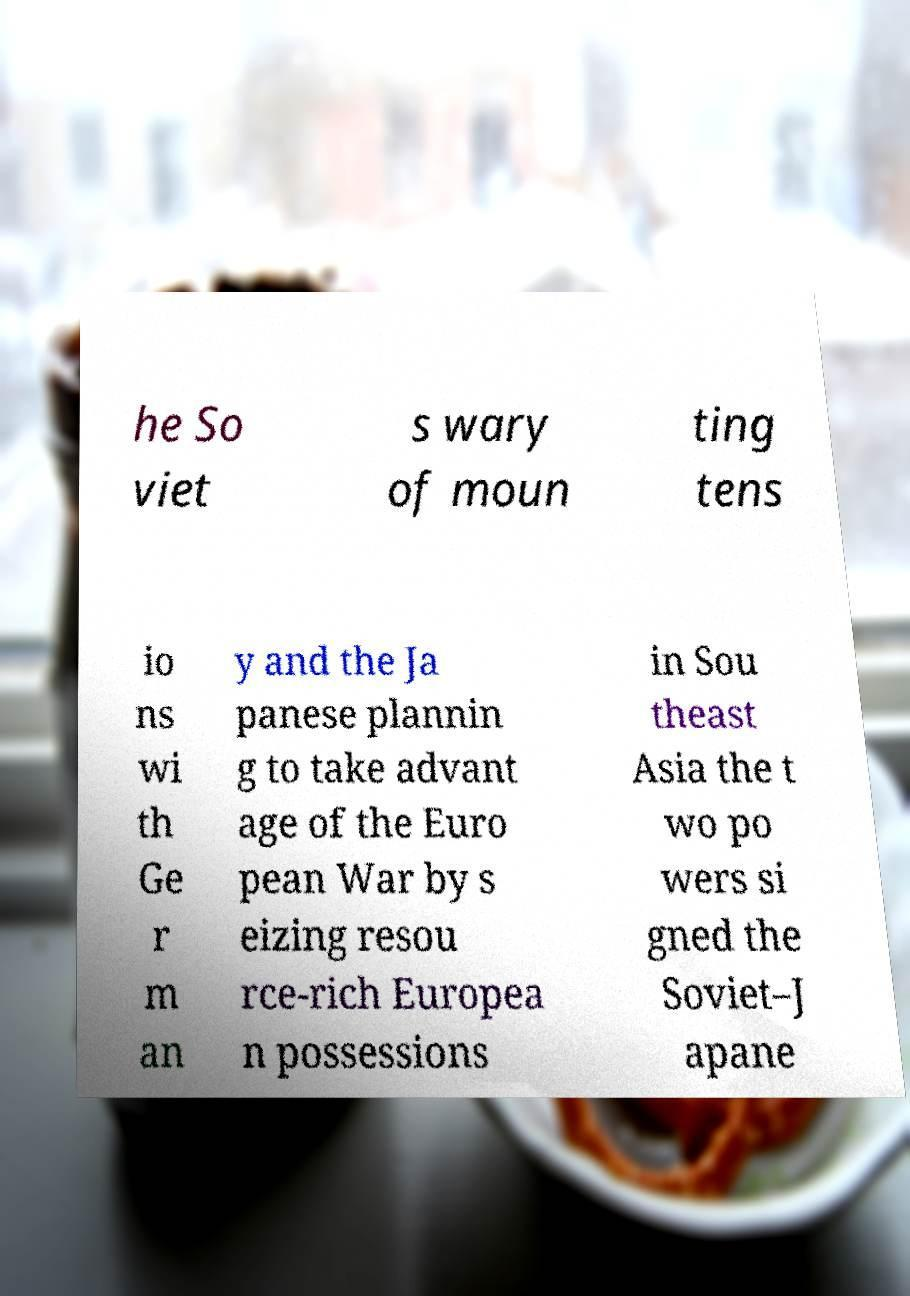Could you assist in decoding the text presented in this image and type it out clearly? he So viet s wary of moun ting tens io ns wi th Ge r m an y and the Ja panese plannin g to take advant age of the Euro pean War by s eizing resou rce-rich Europea n possessions in Sou theast Asia the t wo po wers si gned the Soviet–J apane 